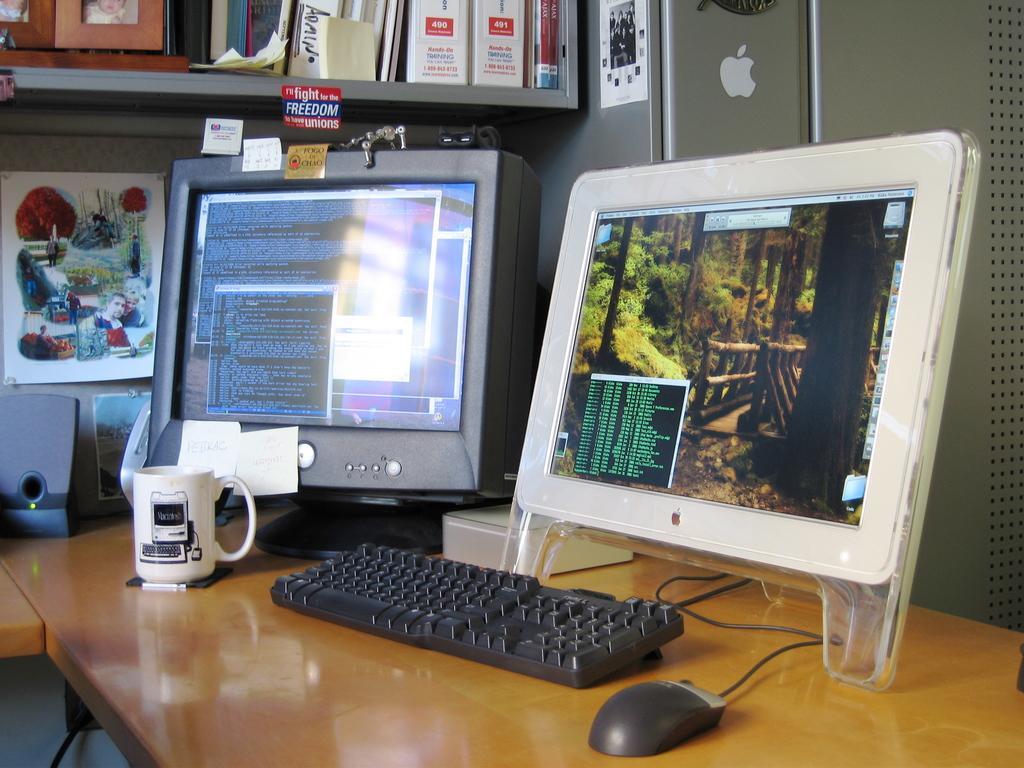Can you describe this image briefly? This picture is of inside. On the right there is a table on the top of which a mug, keyboard, mouse, monitor and a picture frame is placed. On the left corner there is a cabinet including books and picture frames. In the background we can see a wall and a machine. 